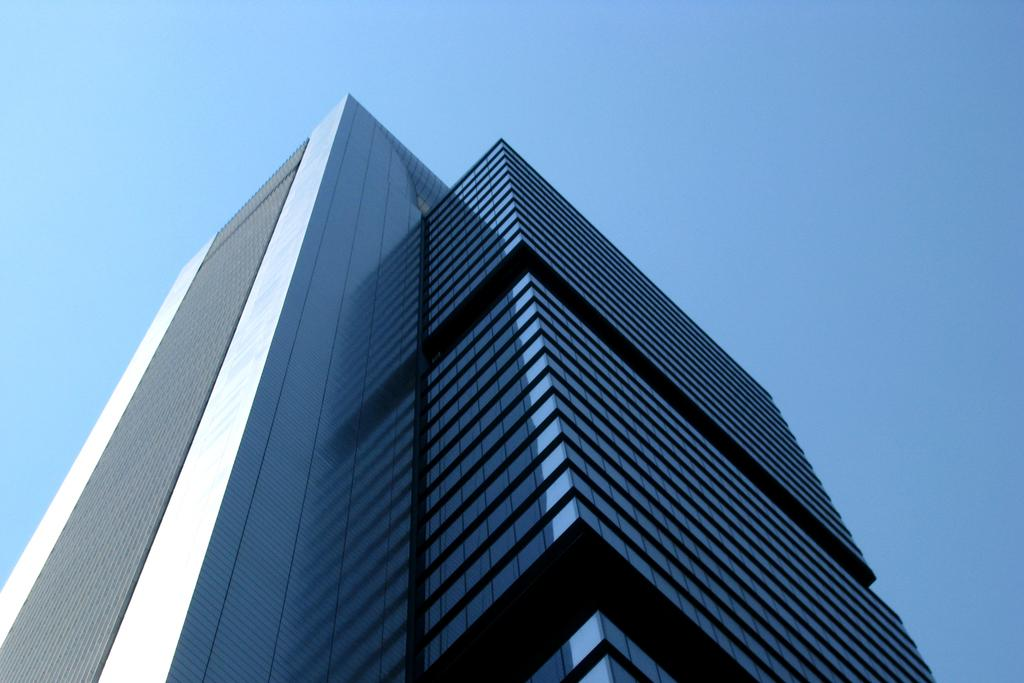What type of structure is visible in the image? There is a building in the image. What type of metal is used to construct the volleyball court in the image? There is no volleyball court present in the image, and therefore no metal construction can be observed. 